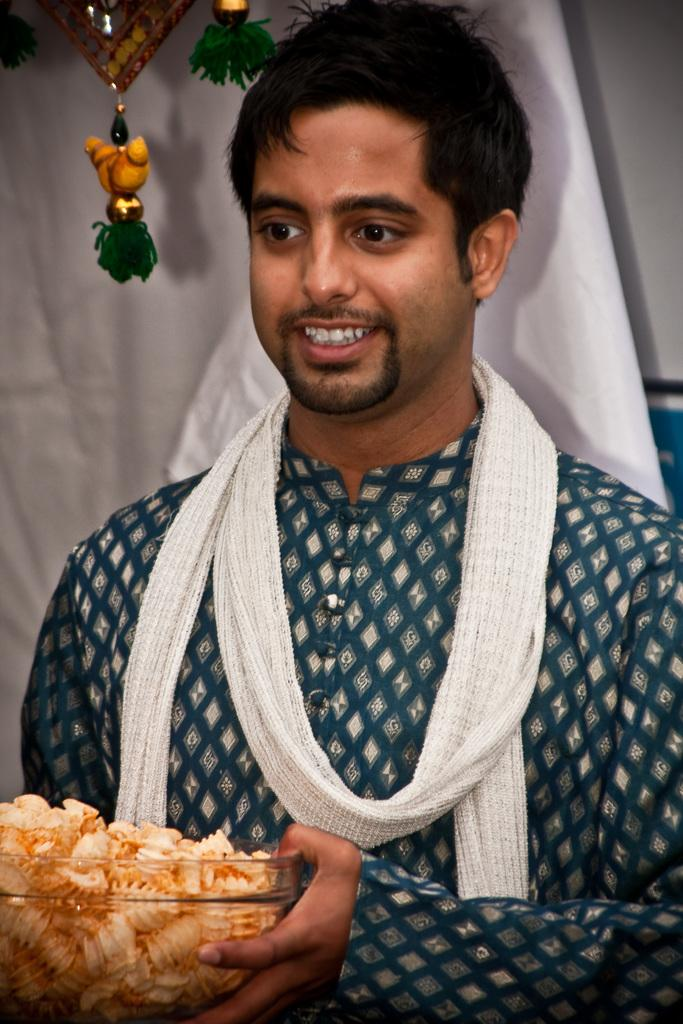What is the person in the image doing? The person is holding a bowl with food. How is the person feeling in the image? The person is smiling, which suggests they are happy or enjoying themselves. What can be seen in the background of the image? There is a cloth in the background of the image. What is present on the left side top of the image? Hangings are present on the left side top of the image. What type of agreement is being discussed in the image? There is no indication of an agreement being discussed in the image; it primarily features a person holding a bowl with food and smiling. 